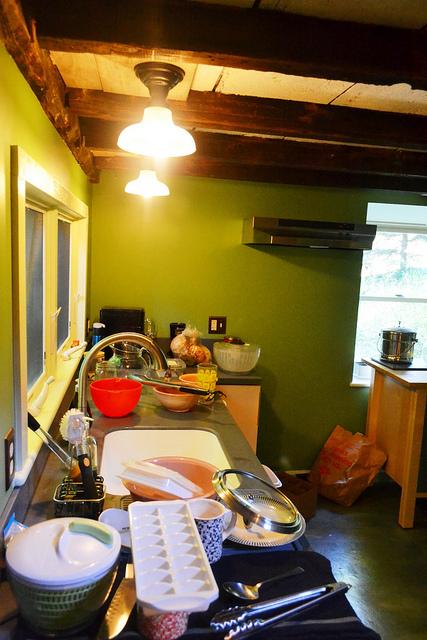What color is the ice cube tray on the left?
Write a very short answer. White. What room in a house is this?
Quick response, please. Kitchen. What is the bowl with the white lid called?
Answer briefly. Salad spinner. 